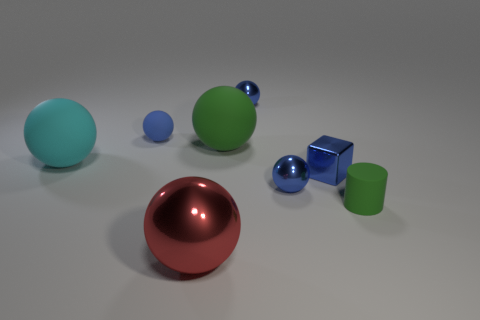What number of red shiny things are to the left of the large red object?
Give a very brief answer. 0. Is the number of green cylinders greater than the number of small objects?
Your response must be concise. No. There is a object that is both on the left side of the green ball and in front of the cyan rubber sphere; what is its shape?
Your answer should be very brief. Sphere. Are any small brown matte things visible?
Give a very brief answer. No. There is a big cyan thing that is the same shape as the big green rubber object; what is its material?
Your answer should be very brief. Rubber. There is a large object in front of the big matte ball that is to the left of the ball in front of the cylinder; what shape is it?
Provide a succinct answer. Sphere. What is the material of the large thing that is the same color as the matte cylinder?
Keep it short and to the point. Rubber. How many other objects have the same shape as the large green object?
Your answer should be very brief. 5. Is the color of the small sphere that is to the left of the large red shiny thing the same as the tiny sphere that is in front of the big green rubber thing?
Provide a succinct answer. Yes. There is a block that is the same size as the green cylinder; what material is it?
Ensure brevity in your answer.  Metal. 